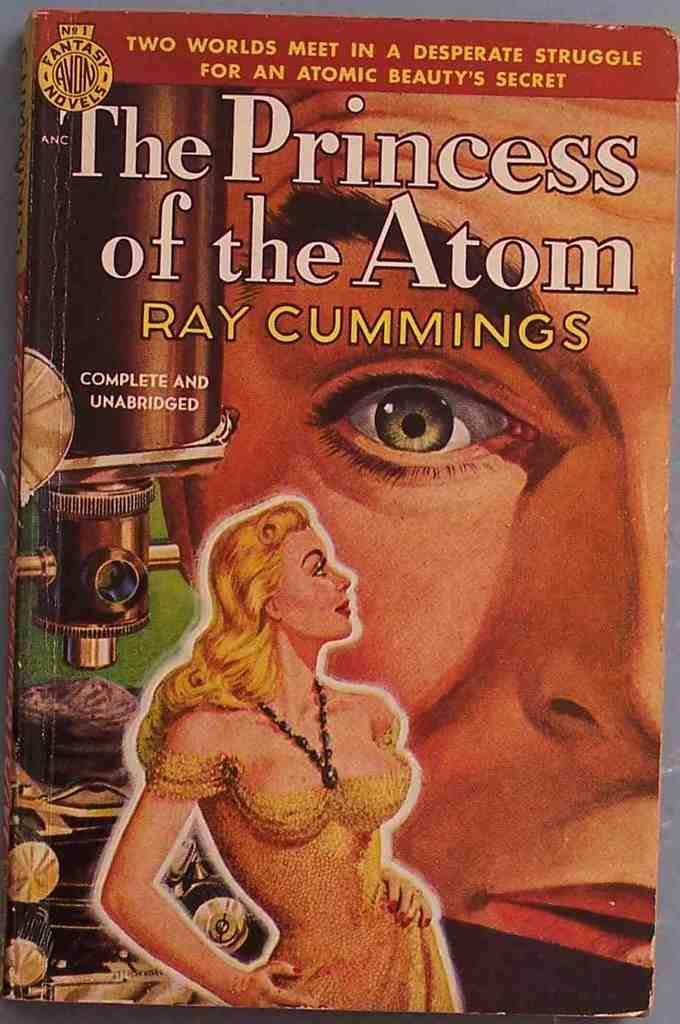<image>
Relay a brief, clear account of the picture shown. A book by Ray Cummings called The Princess of the atom 